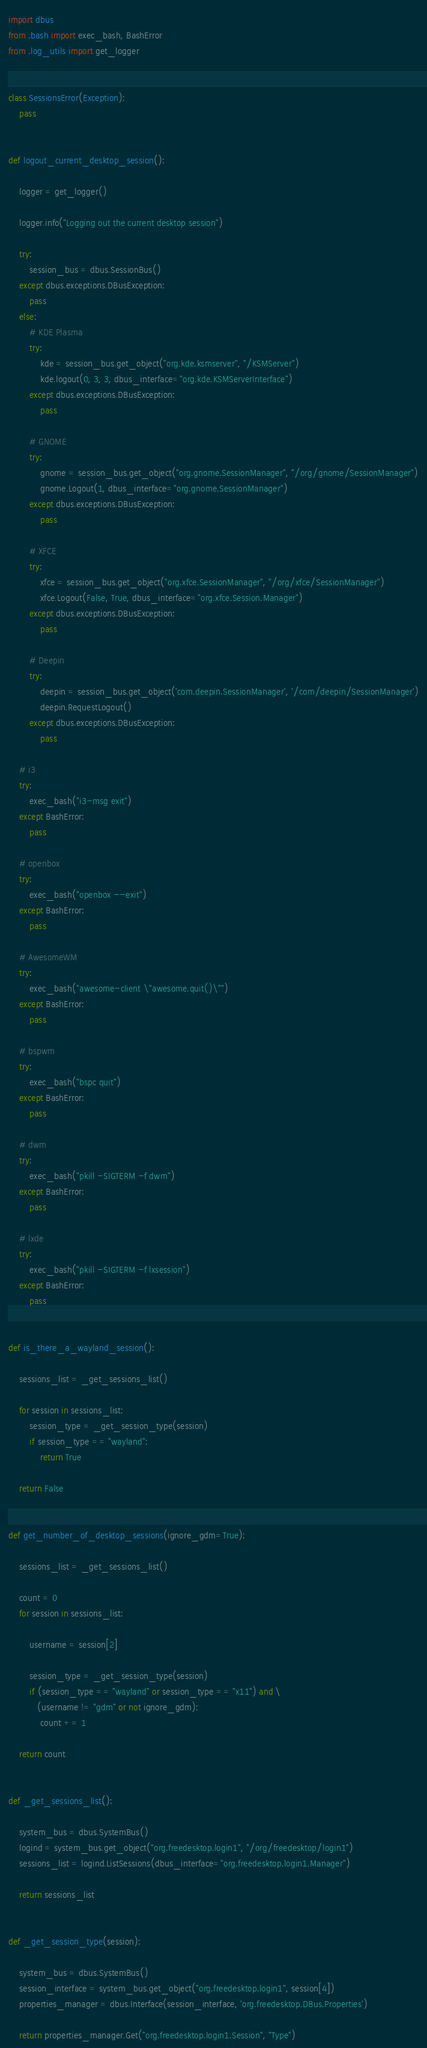Convert code to text. <code><loc_0><loc_0><loc_500><loc_500><_Python_>import dbus
from .bash import exec_bash, BashError
from .log_utils import get_logger


class SessionsError(Exception):
    pass


def logout_current_desktop_session():

    logger = get_logger()

    logger.info("Logging out the current desktop session")

    try:
        session_bus = dbus.SessionBus()
    except dbus.exceptions.DBusException:
        pass
    else:
        # KDE Plasma
        try:
            kde = session_bus.get_object("org.kde.ksmserver", "/KSMServer")
            kde.logout(0, 3, 3, dbus_interface="org.kde.KSMServerInterface")
        except dbus.exceptions.DBusException:
            pass

        # GNOME
        try:
            gnome = session_bus.get_object("org.gnome.SessionManager", "/org/gnome/SessionManager")
            gnome.Logout(1, dbus_interface="org.gnome.SessionManager")
        except dbus.exceptions.DBusException:
            pass

        # XFCE
        try:
            xfce = session_bus.get_object("org.xfce.SessionManager", "/org/xfce/SessionManager")
            xfce.Logout(False, True, dbus_interface="org.xfce.Session.Manager")
        except dbus.exceptions.DBusException:
            pass

        # Deepin
        try:
            deepin = session_bus.get_object('com.deepin.SessionManager', '/com/deepin/SessionManager')
            deepin.RequestLogout()
        except dbus.exceptions.DBusException:
            pass

    # i3
    try:
        exec_bash("i3-msg exit")
    except BashError:
        pass

    # openbox
    try:
        exec_bash("openbox --exit")
    except BashError:
        pass

    # AwesomeWM
    try:
        exec_bash("awesome-client \"awesome.quit()\"")
    except BashError:
        pass

    # bspwm
    try:
        exec_bash("bspc quit")
    except BashError:
        pass

    # dwm
    try:
        exec_bash("pkill -SIGTERM -f dwm")
    except BashError:
        pass

    # lxde
    try:
        exec_bash("pkill -SIGTERM -f lxsession")
    except BashError:
        pass


def is_there_a_wayland_session():

    sessions_list = _get_sessions_list()

    for session in sessions_list:
        session_type = _get_session_type(session)
        if session_type == "wayland":
            return True

    return False


def get_number_of_desktop_sessions(ignore_gdm=True):

    sessions_list = _get_sessions_list()

    count = 0
    for session in sessions_list:

        username = session[2]

        session_type = _get_session_type(session)
        if (session_type == "wayland" or session_type == "x11") and \
           (username != "gdm" or not ignore_gdm):
            count += 1

    return count


def _get_sessions_list():

    system_bus = dbus.SystemBus()
    logind = system_bus.get_object("org.freedesktop.login1", "/org/freedesktop/login1")
    sessions_list = logind.ListSessions(dbus_interface="org.freedesktop.login1.Manager")

    return sessions_list


def _get_session_type(session):

    system_bus = dbus.SystemBus()
    session_interface = system_bus.get_object("org.freedesktop.login1", session[4])
    properties_manager = dbus.Interface(session_interface, 'org.freedesktop.DBus.Properties')

    return properties_manager.Get("org.freedesktop.login1.Session", "Type")
</code> 